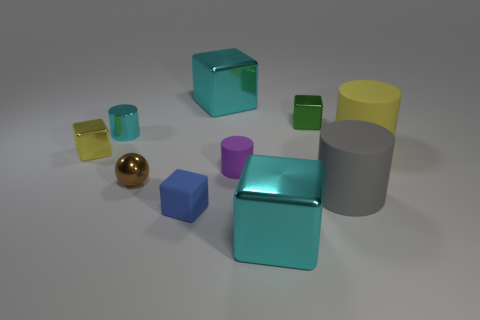There is a yellow object that is the same material as the green block; what size is it?
Offer a very short reply. Small. Is the material of the ball the same as the gray thing?
Ensure brevity in your answer.  No. The tiny matte object that is right of the big thing that is behind the large rubber cylinder that is behind the brown metallic thing is what color?
Provide a succinct answer. Purple. What is the shape of the yellow rubber thing?
Your answer should be compact. Cylinder. There is a metal cylinder; is it the same color as the metal cube in front of the blue object?
Give a very brief answer. Yes. Are there an equal number of tiny blue cubes that are behind the large yellow thing and brown matte spheres?
Offer a terse response. Yes. How many brown metal balls are the same size as the yellow matte cylinder?
Give a very brief answer. 0. Are there any big brown rubber cylinders?
Offer a terse response. No. Is the shape of the large matte thing that is to the right of the large gray cylinder the same as the big rubber thing that is in front of the large yellow cylinder?
Your answer should be compact. Yes. How many small things are either purple metal cylinders or cubes?
Ensure brevity in your answer.  3. 